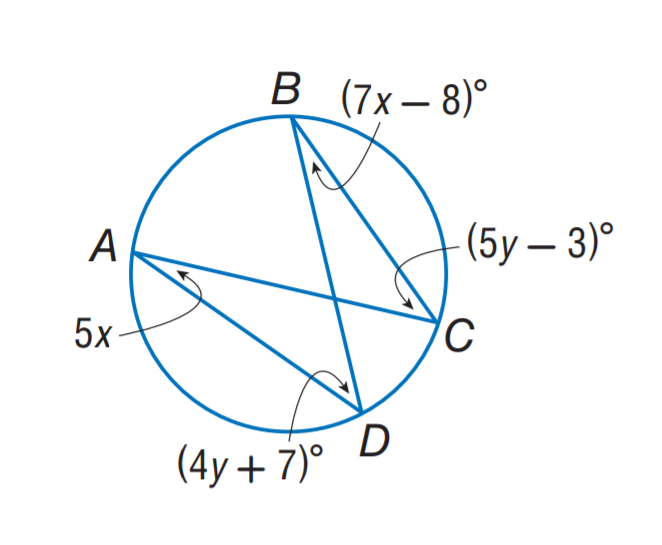Question: Find m \angle C.
Choices:
A. 17
B. 20
C. 33
D. 47
Answer with the letter. Answer: D Question: Find m \angle A.
Choices:
A. 17
B. 20
C. 33
D. 47
Answer with the letter. Answer: B 